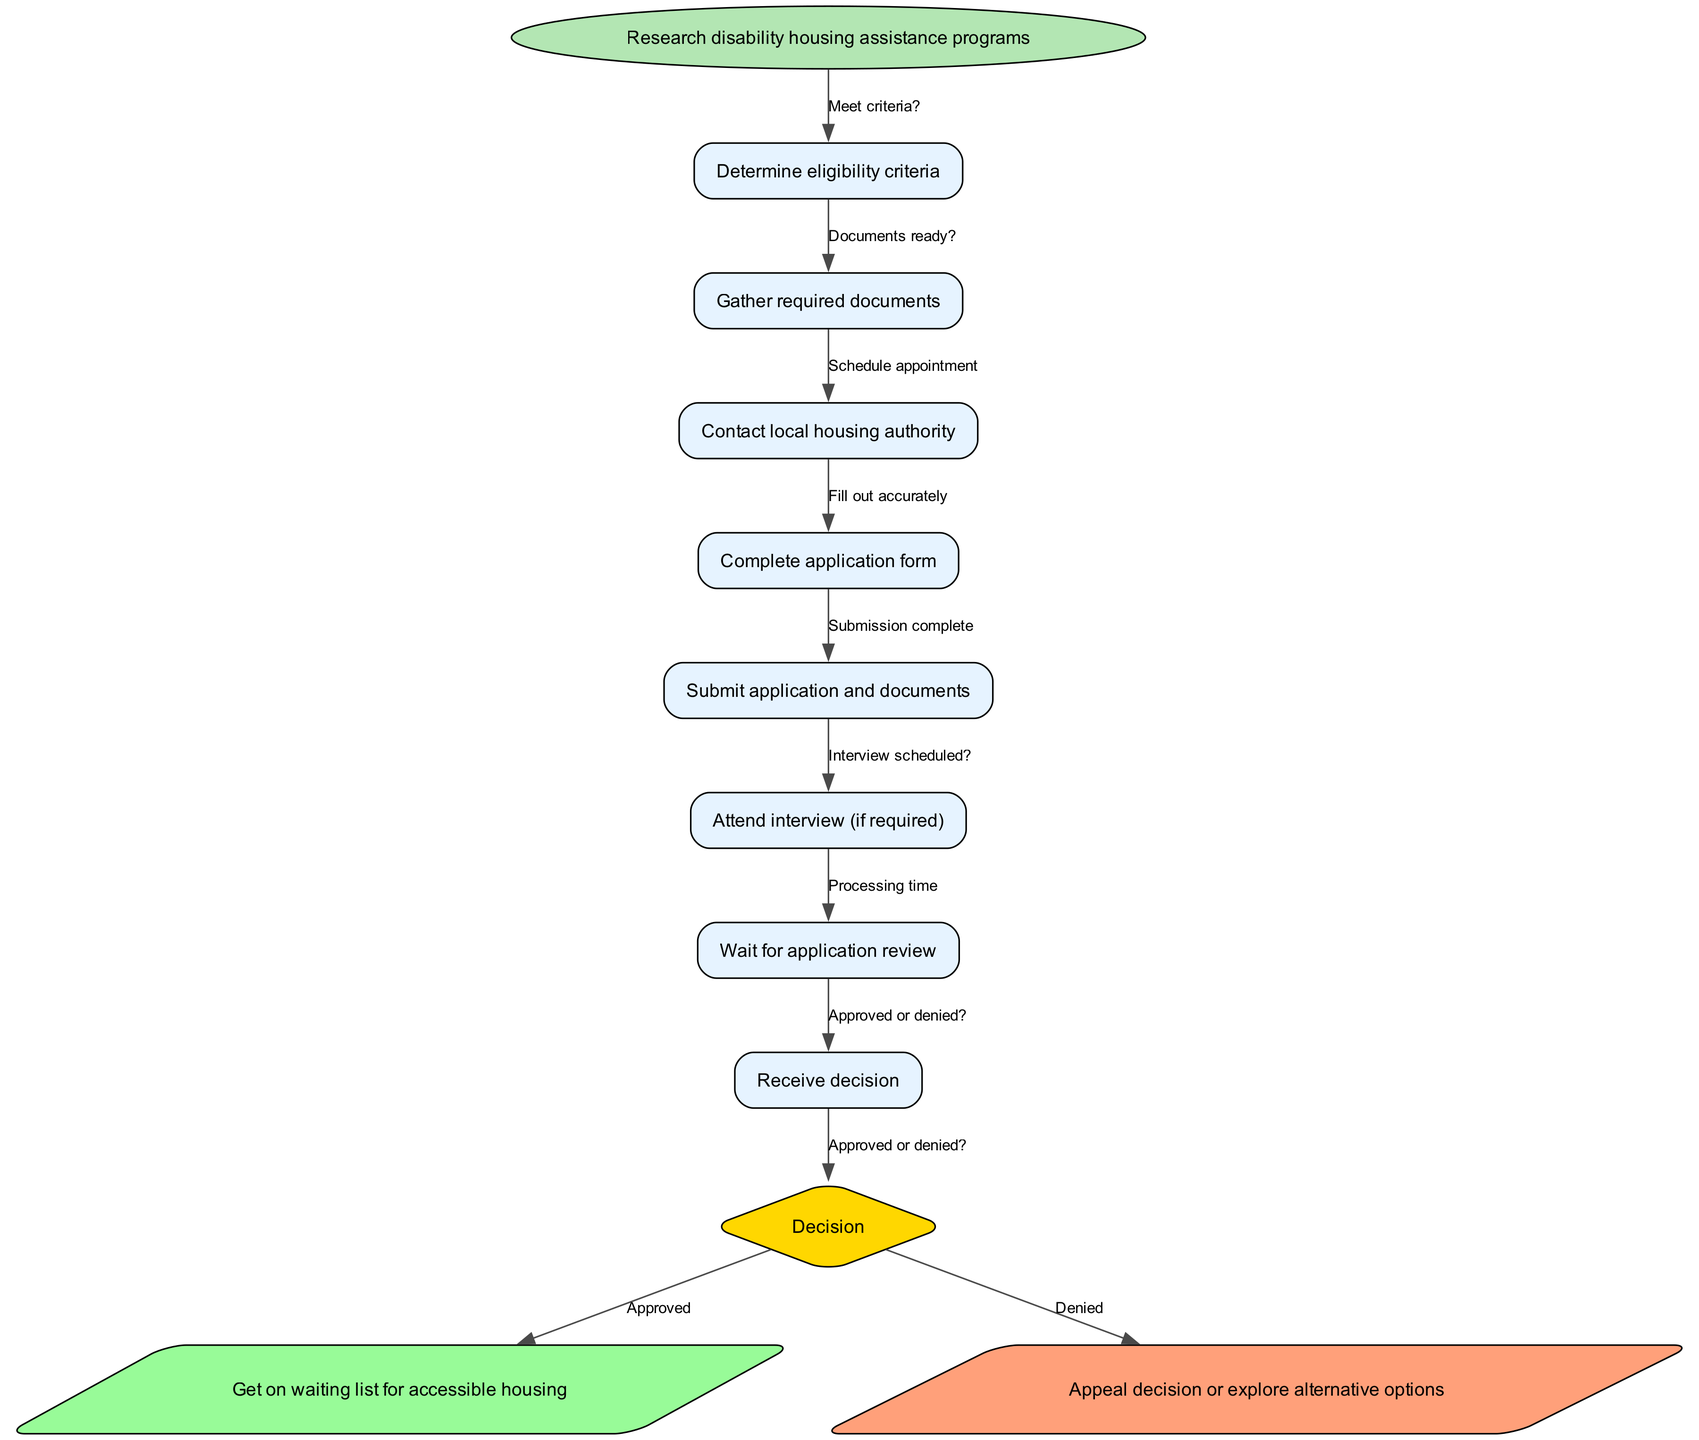What is the first step in the application process? The first step indicated in the diagram is "Research disability housing assistance programs." This node represents the starting point before moving into further steps.
Answer: Research disability housing assistance programs How many nodes are present in the diagram? The diagram lists eight process nodes plus the start node and decision node, totaling ten nodes. The process nodes include eligibility criteria, document gathering, and so on.
Answer: 10 What is the last step before the decision point? The last process node before the decision point is "Wait for application review." This is the final part of the standard process before receiving a decision.
Answer: Wait for application review What action follows an "Approved" decision? If the decision is "Approved," the next action is "Get on waiting list for accessible housing." This is the resulting step that follows a successful application.
Answer: Get on waiting list for accessible housing What is the relationship between "Gather required documents" and "Complete application form"? "Gather required documents" links directly to "Complete application form" as the second and third nodes, respectively, indicating that document preparation is a prerequisite for completing the application form.
Answer: Documents ready? If the application is denied, what can an applicant do? If the application is denied, the applicant has two options: "Appeal decision or explore alternative options." This presents the choices available after a negative outcome.
Answer: Appeal decision or explore alternative options How many total edges connect the nodes in the diagram? There are eight edges connecting the nodes as each step is followed by a question that determines whether to proceed or what to do next, leading to a decision edge.
Answer: 8 What does the diamond shape represent in the diagram? The diamond shape represents a decision point in the process. In this case, it indicates the evaluation of the application outcome, categorized as either "Approved" or "Denied."
Answer: Decision What comes after "Attend interview (if required)"? After "Attend interview (if required)," the next step is "Wait for application review," indicating that once the interview is done, the applicant must wait for the evaluation process.
Answer: Wait for application review 